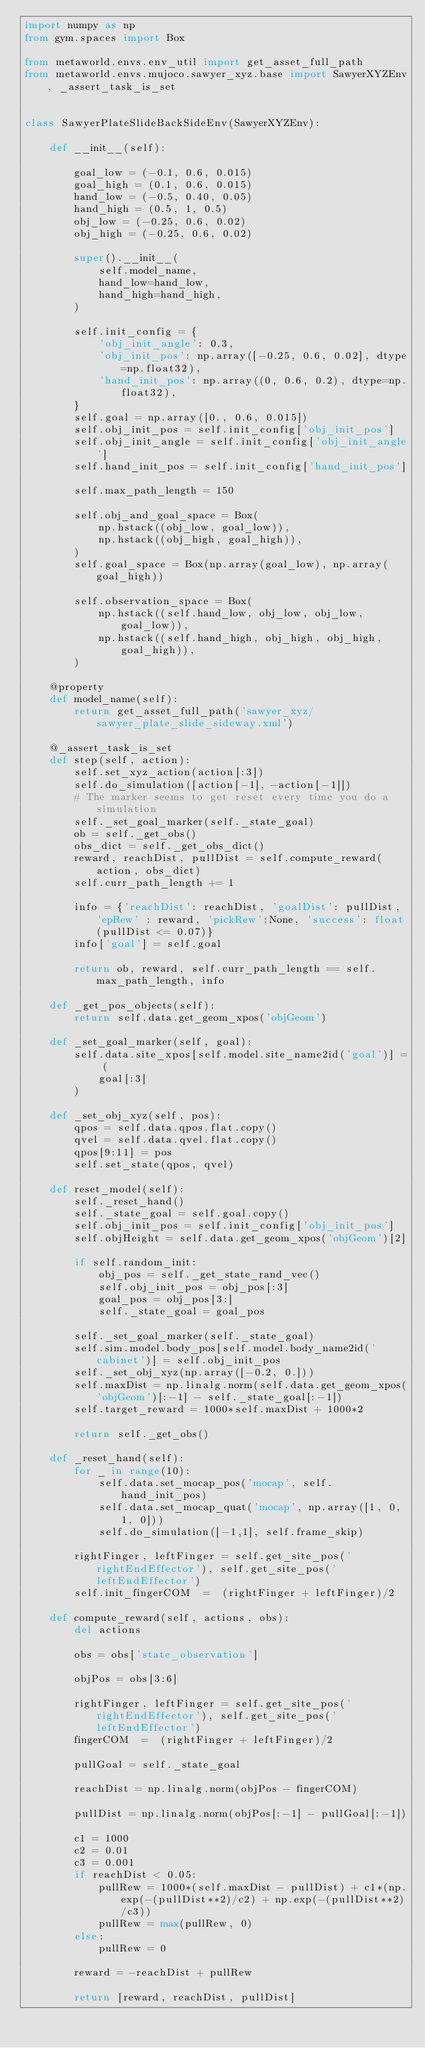<code> <loc_0><loc_0><loc_500><loc_500><_Python_>import numpy as np
from gym.spaces import Box

from metaworld.envs.env_util import get_asset_full_path
from metaworld.envs.mujoco.sawyer_xyz.base import SawyerXYZEnv, _assert_task_is_set


class SawyerPlateSlideBackSideEnv(SawyerXYZEnv):

    def __init__(self):

        goal_low = (-0.1, 0.6, 0.015)
        goal_high = (0.1, 0.6, 0.015)
        hand_low = (-0.5, 0.40, 0.05)
        hand_high = (0.5, 1, 0.5)
        obj_low = (-0.25, 0.6, 0.02)
        obj_high = (-0.25, 0.6, 0.02)

        super().__init__(
            self.model_name,
            hand_low=hand_low,
            hand_high=hand_high,
        )

        self.init_config = {
            'obj_init_angle': 0.3,
            'obj_init_pos': np.array([-0.25, 0.6, 0.02], dtype=np.float32),
            'hand_init_pos': np.array((0, 0.6, 0.2), dtype=np.float32),
        }
        self.goal = np.array([0., 0.6, 0.015])
        self.obj_init_pos = self.init_config['obj_init_pos']
        self.obj_init_angle = self.init_config['obj_init_angle']
        self.hand_init_pos = self.init_config['hand_init_pos']

        self.max_path_length = 150

        self.obj_and_goal_space = Box(
            np.hstack((obj_low, goal_low)),
            np.hstack((obj_high, goal_high)),
        )
        self.goal_space = Box(np.array(goal_low), np.array(goal_high))

        self.observation_space = Box(
            np.hstack((self.hand_low, obj_low, obj_low, goal_low)),
            np.hstack((self.hand_high, obj_high, obj_high, goal_high)),
        )

    @property
    def model_name(self):
        return get_asset_full_path('sawyer_xyz/sawyer_plate_slide_sideway.xml')

    @_assert_task_is_set
    def step(self, action):
        self.set_xyz_action(action[:3])
        self.do_simulation([action[-1], -action[-1]])
        # The marker seems to get reset every time you do a simulation
        self._set_goal_marker(self._state_goal)
        ob = self._get_obs()
        obs_dict = self._get_obs_dict()
        reward, reachDist, pullDist = self.compute_reward(action, obs_dict)
        self.curr_path_length += 1

        info = {'reachDist': reachDist, 'goalDist': pullDist, 'epRew' : reward, 'pickRew':None, 'success': float(pullDist <= 0.07)}
        info['goal'] = self.goal

        return ob, reward, self.curr_path_length == self.max_path_length, info

    def _get_pos_objects(self):
        return self.data.get_geom_xpos('objGeom')

    def _set_goal_marker(self, goal):
        self.data.site_xpos[self.model.site_name2id('goal')] = (
            goal[:3]
        )

    def _set_obj_xyz(self, pos):
        qpos = self.data.qpos.flat.copy()
        qvel = self.data.qvel.flat.copy()
        qpos[9:11] = pos
        self.set_state(qpos, qvel)

    def reset_model(self):
        self._reset_hand()
        self._state_goal = self.goal.copy()
        self.obj_init_pos = self.init_config['obj_init_pos']
        self.objHeight = self.data.get_geom_xpos('objGeom')[2]

        if self.random_init:
            obj_pos = self._get_state_rand_vec()
            self.obj_init_pos = obj_pos[:3]
            goal_pos = obj_pos[3:]
            self._state_goal = goal_pos

        self._set_goal_marker(self._state_goal)
        self.sim.model.body_pos[self.model.body_name2id('cabinet')] = self.obj_init_pos
        self._set_obj_xyz(np.array([-0.2, 0.]))
        self.maxDist = np.linalg.norm(self.data.get_geom_xpos('objGeom')[:-1] - self._state_goal[:-1])
        self.target_reward = 1000*self.maxDist + 1000*2

        return self._get_obs()

    def _reset_hand(self):
        for _ in range(10):
            self.data.set_mocap_pos('mocap', self.hand_init_pos)
            self.data.set_mocap_quat('mocap', np.array([1, 0, 1, 0]))
            self.do_simulation([-1,1], self.frame_skip)

        rightFinger, leftFinger = self.get_site_pos('rightEndEffector'), self.get_site_pos('leftEndEffector')
        self.init_fingerCOM  =  (rightFinger + leftFinger)/2

    def compute_reward(self, actions, obs):
        del actions

        obs = obs['state_observation']

        objPos = obs[3:6]

        rightFinger, leftFinger = self.get_site_pos('rightEndEffector'), self.get_site_pos('leftEndEffector')
        fingerCOM  =  (rightFinger + leftFinger)/2

        pullGoal = self._state_goal

        reachDist = np.linalg.norm(objPos - fingerCOM)

        pullDist = np.linalg.norm(objPos[:-1] - pullGoal[:-1])

        c1 = 1000
        c2 = 0.01
        c3 = 0.001
        if reachDist < 0.05:
            pullRew = 1000*(self.maxDist - pullDist) + c1*(np.exp(-(pullDist**2)/c2) + np.exp(-(pullDist**2)/c3))
            pullRew = max(pullRew, 0)
        else:
            pullRew = 0

        reward = -reachDist + pullRew

        return [reward, reachDist, pullDist]
</code> 